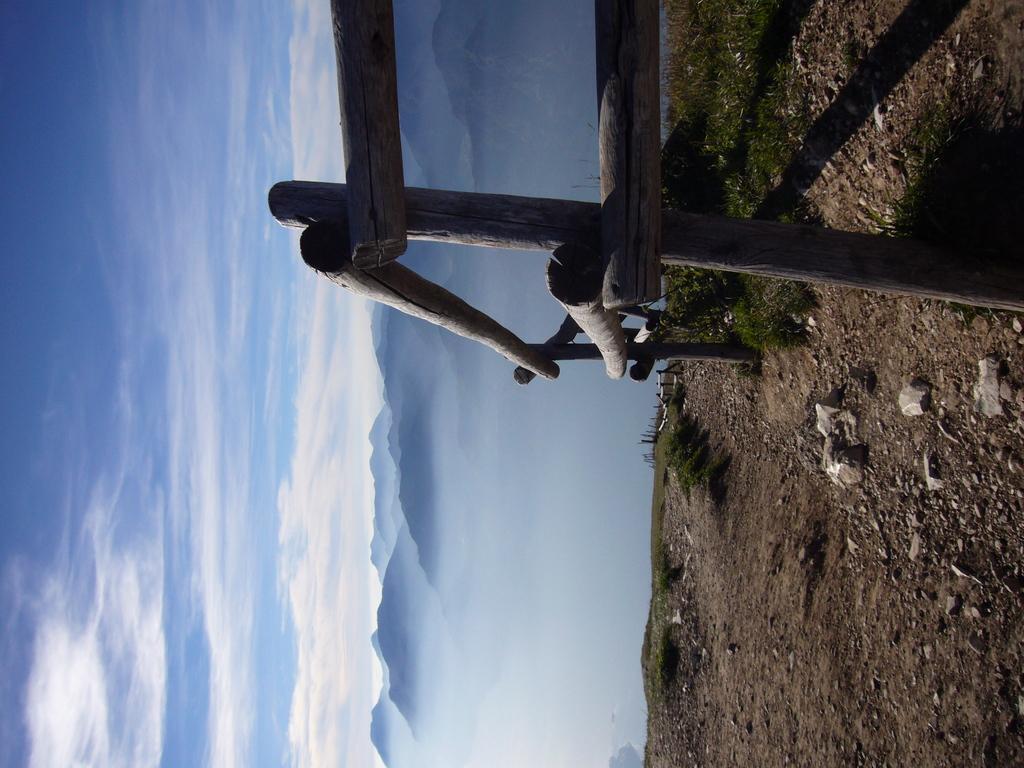Could you give a brief overview of what you see in this image? In this image we can see wooden fence, stones, grass and plants on the ground. In the background we can see mountains and clouds in the sky. 